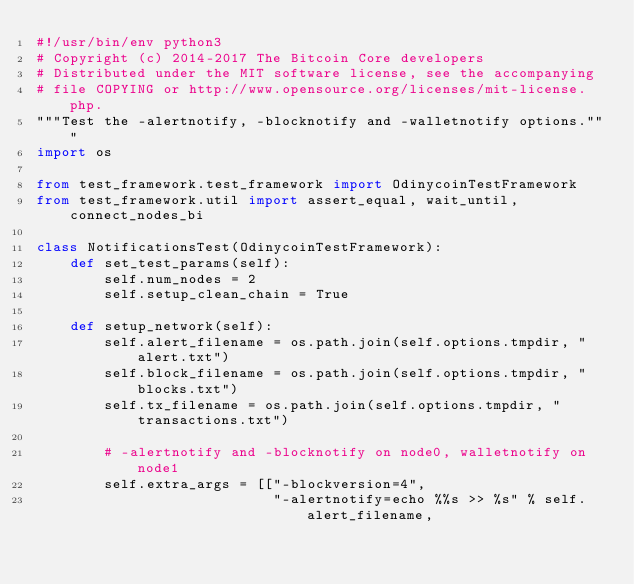<code> <loc_0><loc_0><loc_500><loc_500><_Python_>#!/usr/bin/env python3
# Copyright (c) 2014-2017 The Bitcoin Core developers
# Distributed under the MIT software license, see the accompanying
# file COPYING or http://www.opensource.org/licenses/mit-license.php.
"""Test the -alertnotify, -blocknotify and -walletnotify options."""
import os

from test_framework.test_framework import OdinycoinTestFramework
from test_framework.util import assert_equal, wait_until, connect_nodes_bi

class NotificationsTest(OdinycoinTestFramework):
    def set_test_params(self):
        self.num_nodes = 2
        self.setup_clean_chain = True

    def setup_network(self):
        self.alert_filename = os.path.join(self.options.tmpdir, "alert.txt")
        self.block_filename = os.path.join(self.options.tmpdir, "blocks.txt")
        self.tx_filename = os.path.join(self.options.tmpdir, "transactions.txt")

        # -alertnotify and -blocknotify on node0, walletnotify on node1
        self.extra_args = [["-blockversion=4",
                            "-alertnotify=echo %%s >> %s" % self.alert_filename,</code> 